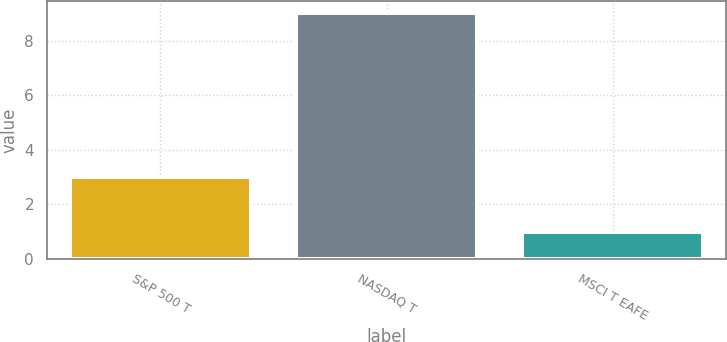<chart> <loc_0><loc_0><loc_500><loc_500><bar_chart><fcel>S&P 500 T<fcel>NASDAQ T<fcel>MSCI T EAFE<nl><fcel>3<fcel>9<fcel>1<nl></chart> 